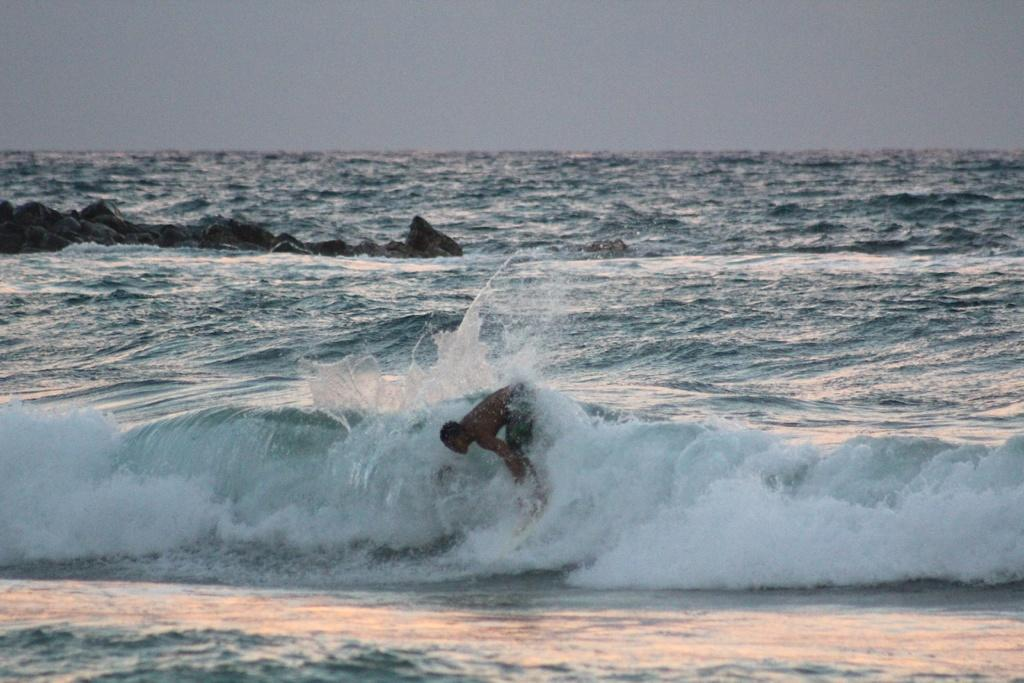Who is the main subject in the image? There is a man in the image. What is the man doing in the image? The man is surfing on water. What tool is the man using to surf? The man is using a surfboard. What can be seen in the background of the image? There are rocks and the sky visible in the background of the image. What time is displayed on the clock in the image? There is no clock present in the image. Can you describe the trick the man is performing on the surfboard? The image does not depict a trick being performed; the man is simply surfing on water using a surfboard. 